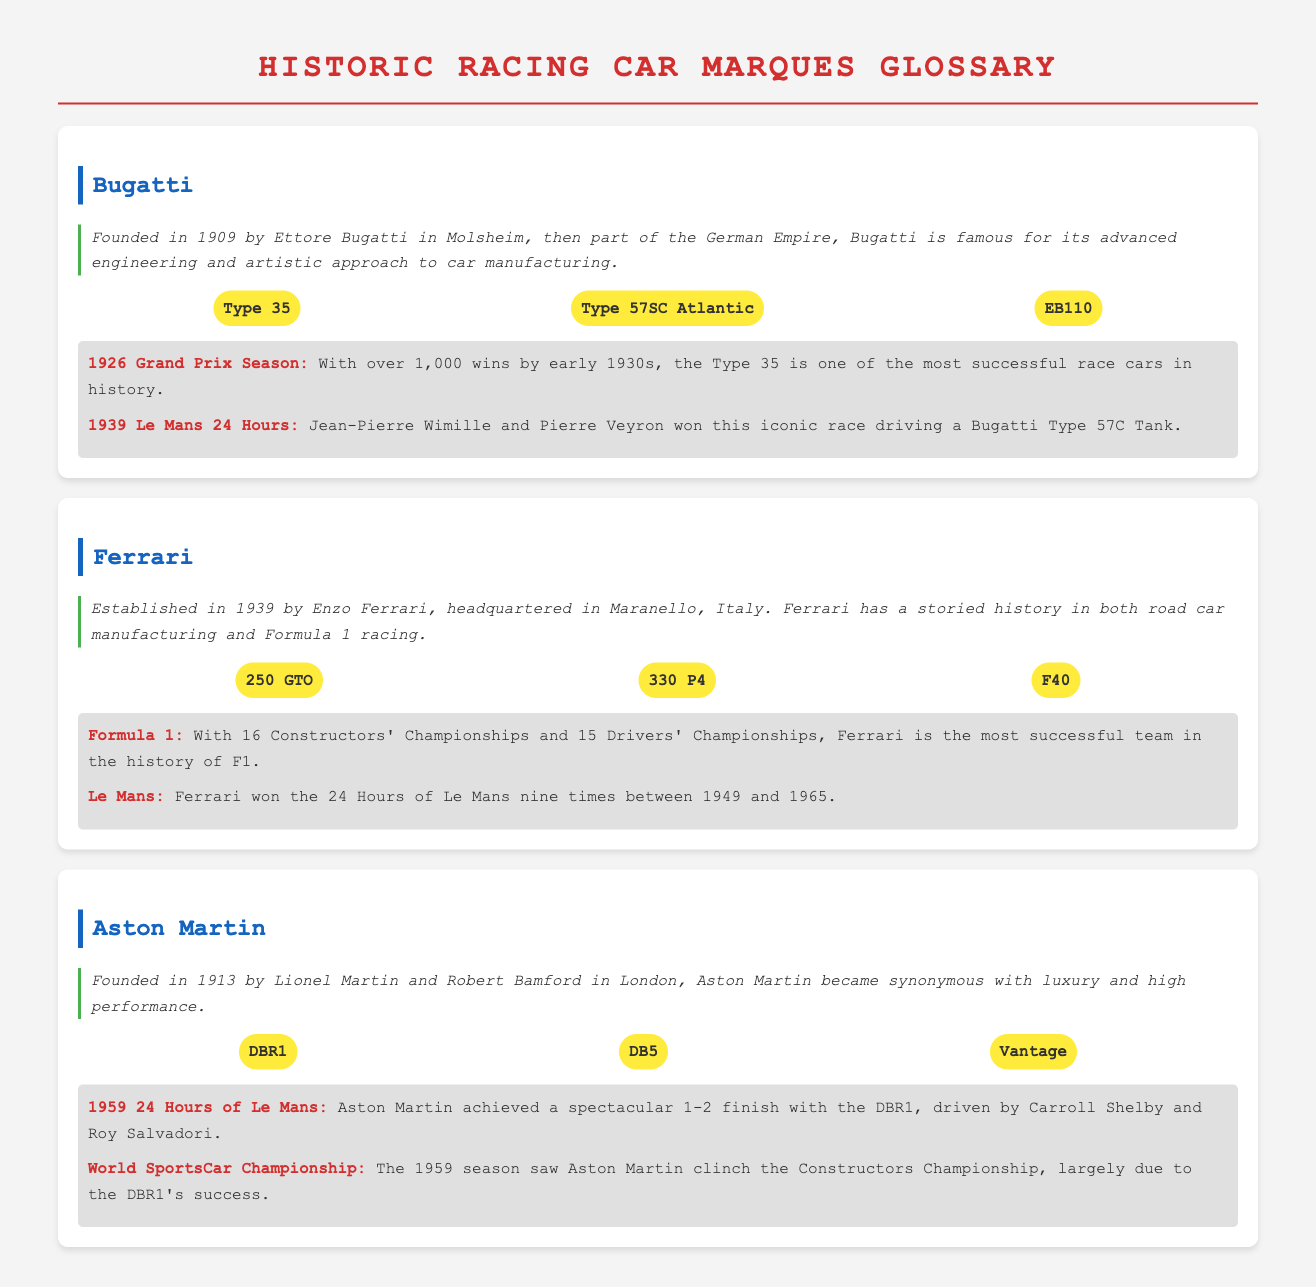What year was Bugatti founded? Bugatti was founded in 1909, and this information is detailed in the heritage section.
Answer: 1909 Which car is considered the most successful race car in history according to Bugatti? The Type 35 is highlighted in the achievements section as one of the most successful race cars in history.
Answer: Type 35 How many Constructors' Championships has Ferrari won in Formula 1? The document states that Ferrari has won 16 Constructors' Championships, appearing in its achievements section.
Answer: 16 What iconic Aston Martin model achieved a 1-2 finish at the 1959 24 Hours of Le Mans? The achievement section mentions the DBR1 model, which achieved this notable finish.
Answer: DBR1 In what year did Ferrari win the 24 Hours of Le Mans for the last time mentioned in the document? The document indicates that Ferrari won the event nine times between 1949 and 1965, with 1965 being the last victory year mentioned.
Answer: 1965 Who were the drivers of the DBR1 during its victory at the 1959 Le Mans? The achievement section names Carroll Shelby and Roy Salvadori as the drivers of the DBR1 during this victory.
Answer: Carroll Shelby and Roy Salvadori What is the iconic model associated with Ferrari mentioned in the document? Ferrari's iconic models such as the 250 GTO, 330 P4, and F40 are listed, showcasing its rich heritage.
Answer: 250 GTO Which racing car brand was founded by Ettore Bugatti? The document clearly states that Bugatti was founded by Ettore Bugatti, as noted in the heritage section.
Answer: Bugatti 